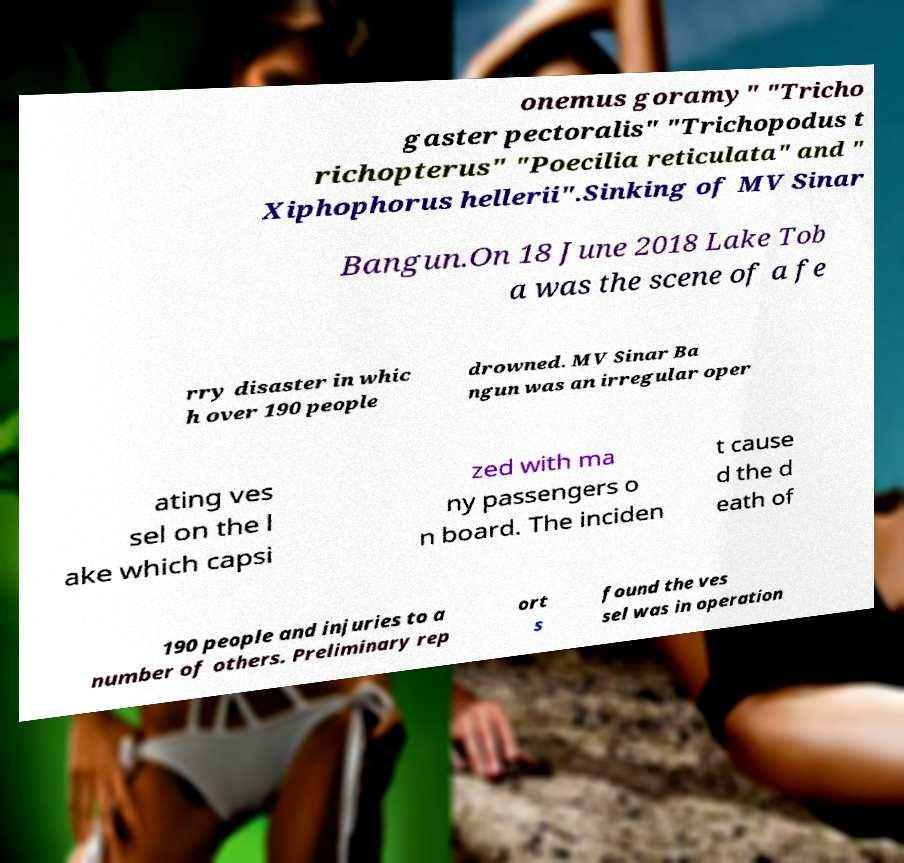Could you extract and type out the text from this image? onemus goramy" "Tricho gaster pectoralis" "Trichopodus t richopterus" "Poecilia reticulata" and " Xiphophorus hellerii".Sinking of MV Sinar Bangun.On 18 June 2018 Lake Tob a was the scene of a fe rry disaster in whic h over 190 people drowned. MV Sinar Ba ngun was an irregular oper ating ves sel on the l ake which capsi zed with ma ny passengers o n board. The inciden t cause d the d eath of 190 people and injuries to a number of others. Preliminary rep ort s found the ves sel was in operation 